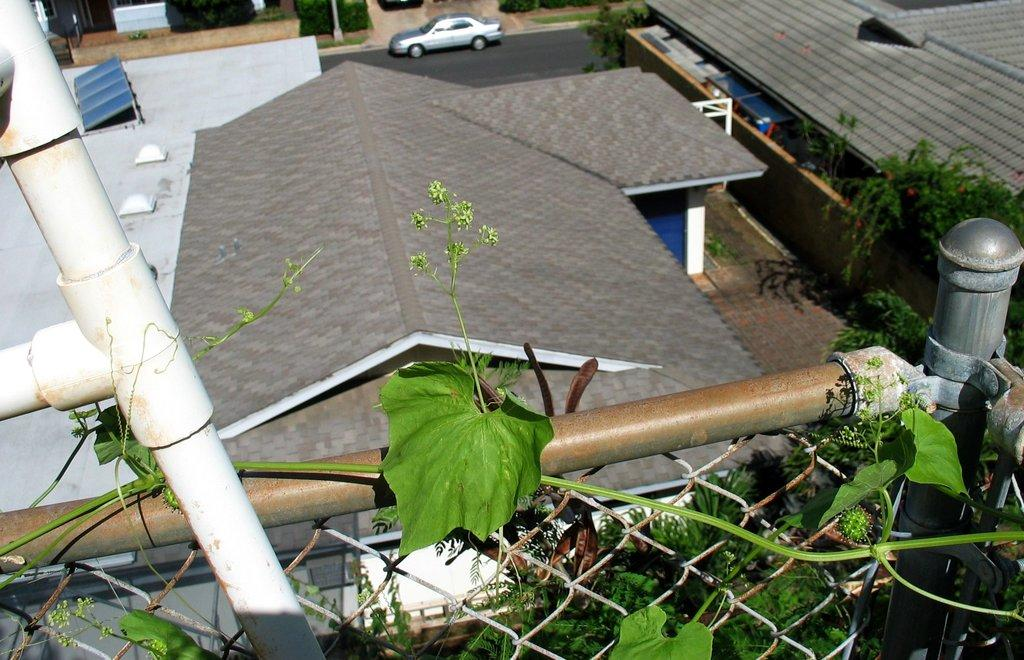What is on the fence in the image? There is a plant leaf on the fence. What can be seen in the background of the image? There are group of buildings, a car, poles, a group of trees, and the sky visible in the background. Can you describe the car in the image? The car is parked on the ground in the background. What type of picture is the person holding in their hands in the image? There is no person holding a picture in their hands in the image. 